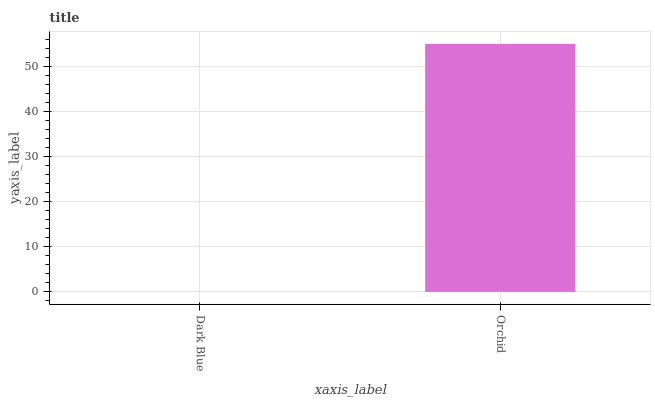Is Dark Blue the minimum?
Answer yes or no. Yes. Is Orchid the maximum?
Answer yes or no. Yes. Is Orchid the minimum?
Answer yes or no. No. Is Orchid greater than Dark Blue?
Answer yes or no. Yes. Is Dark Blue less than Orchid?
Answer yes or no. Yes. Is Dark Blue greater than Orchid?
Answer yes or no. No. Is Orchid less than Dark Blue?
Answer yes or no. No. Is Orchid the high median?
Answer yes or no. Yes. Is Dark Blue the low median?
Answer yes or no. Yes. Is Dark Blue the high median?
Answer yes or no. No. Is Orchid the low median?
Answer yes or no. No. 